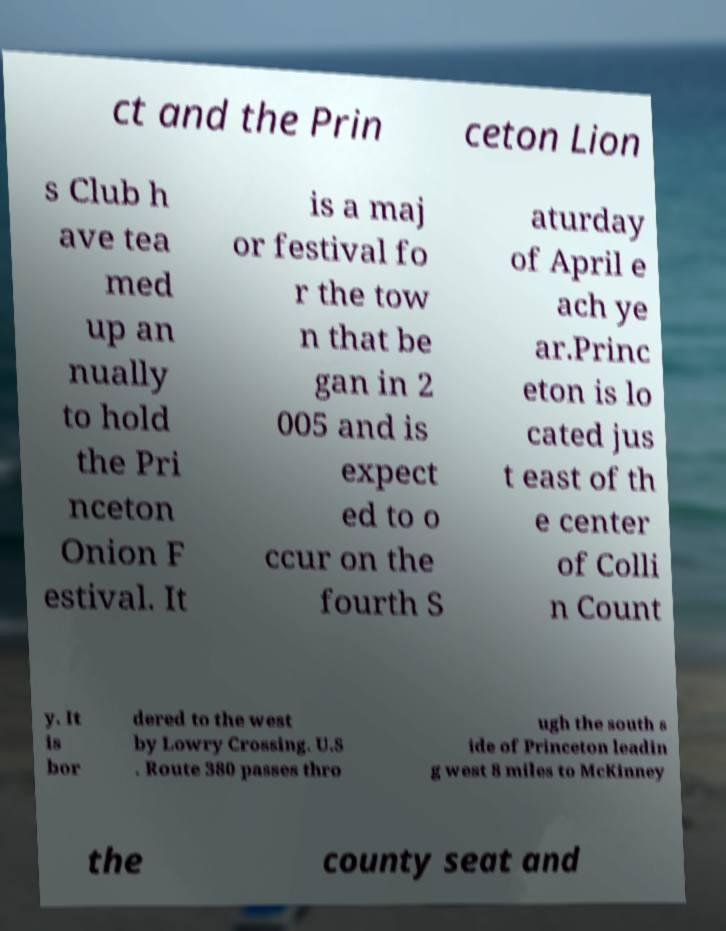Please identify and transcribe the text found in this image. ct and the Prin ceton Lion s Club h ave tea med up an nually to hold the Pri nceton Onion F estival. It is a maj or festival fo r the tow n that be gan in 2 005 and is expect ed to o ccur on the fourth S aturday of April e ach ye ar.Princ eton is lo cated jus t east of th e center of Colli n Count y. It is bor dered to the west by Lowry Crossing. U.S . Route 380 passes thro ugh the south s ide of Princeton leadin g west 8 miles to McKinney the county seat and 